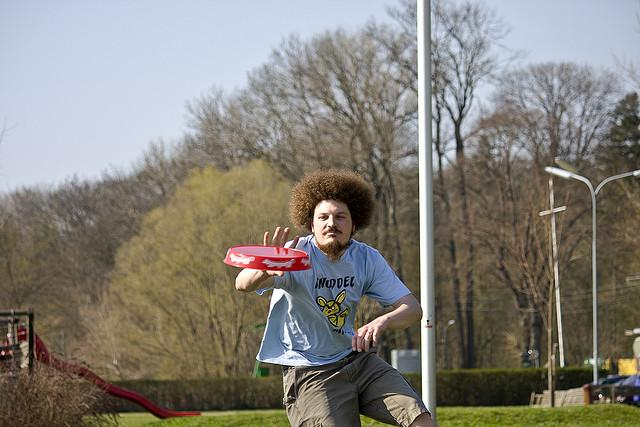What can be played on here?

Choices:
A) trampoline
B) sand box
C) bounce castle
D) slide slide 